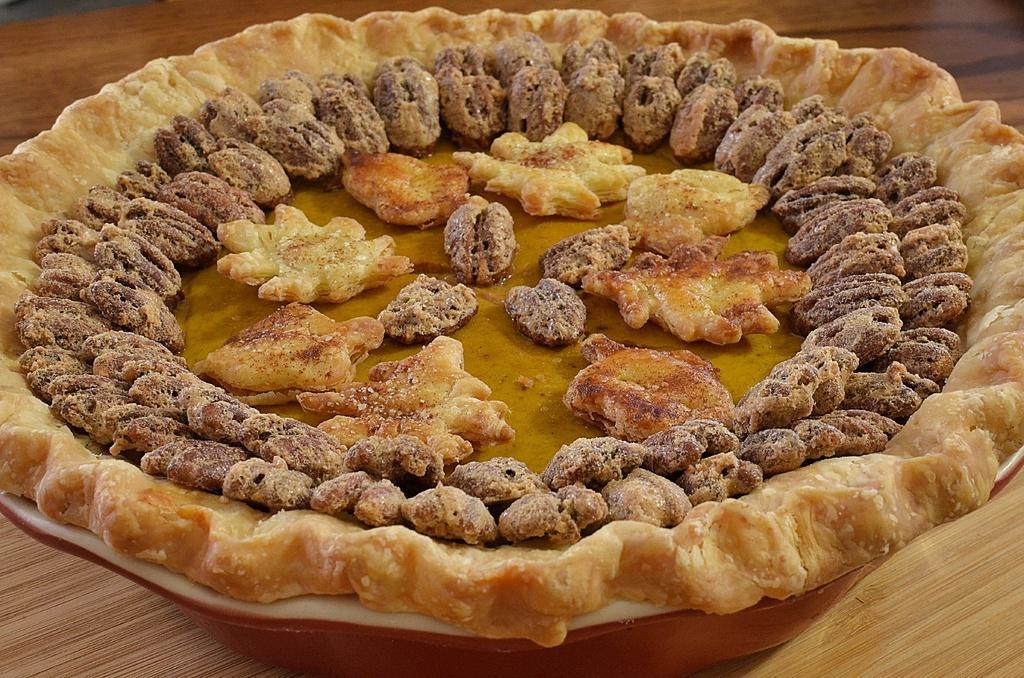In one or two sentences, can you explain what this image depicts? In this image I can see food which is in cream and brown color in the plate and the plate is in white color. 